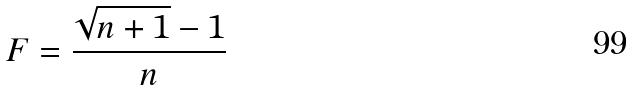Convert formula to latex. <formula><loc_0><loc_0><loc_500><loc_500>F = \frac { \sqrt { n + 1 } - 1 } { n }</formula> 